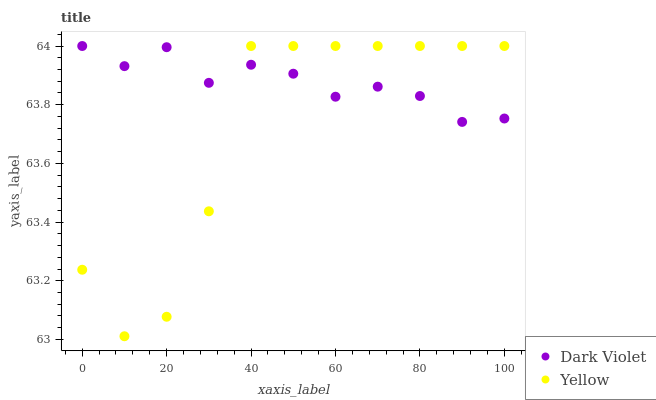Does Yellow have the minimum area under the curve?
Answer yes or no. Yes. Does Dark Violet have the maximum area under the curve?
Answer yes or no. Yes. Does Dark Violet have the minimum area under the curve?
Answer yes or no. No. Is Dark Violet the smoothest?
Answer yes or no. Yes. Is Yellow the roughest?
Answer yes or no. Yes. Is Dark Violet the roughest?
Answer yes or no. No. Does Yellow have the lowest value?
Answer yes or no. Yes. Does Dark Violet have the lowest value?
Answer yes or no. No. Does Dark Violet have the highest value?
Answer yes or no. Yes. Does Yellow intersect Dark Violet?
Answer yes or no. Yes. Is Yellow less than Dark Violet?
Answer yes or no. No. Is Yellow greater than Dark Violet?
Answer yes or no. No. 